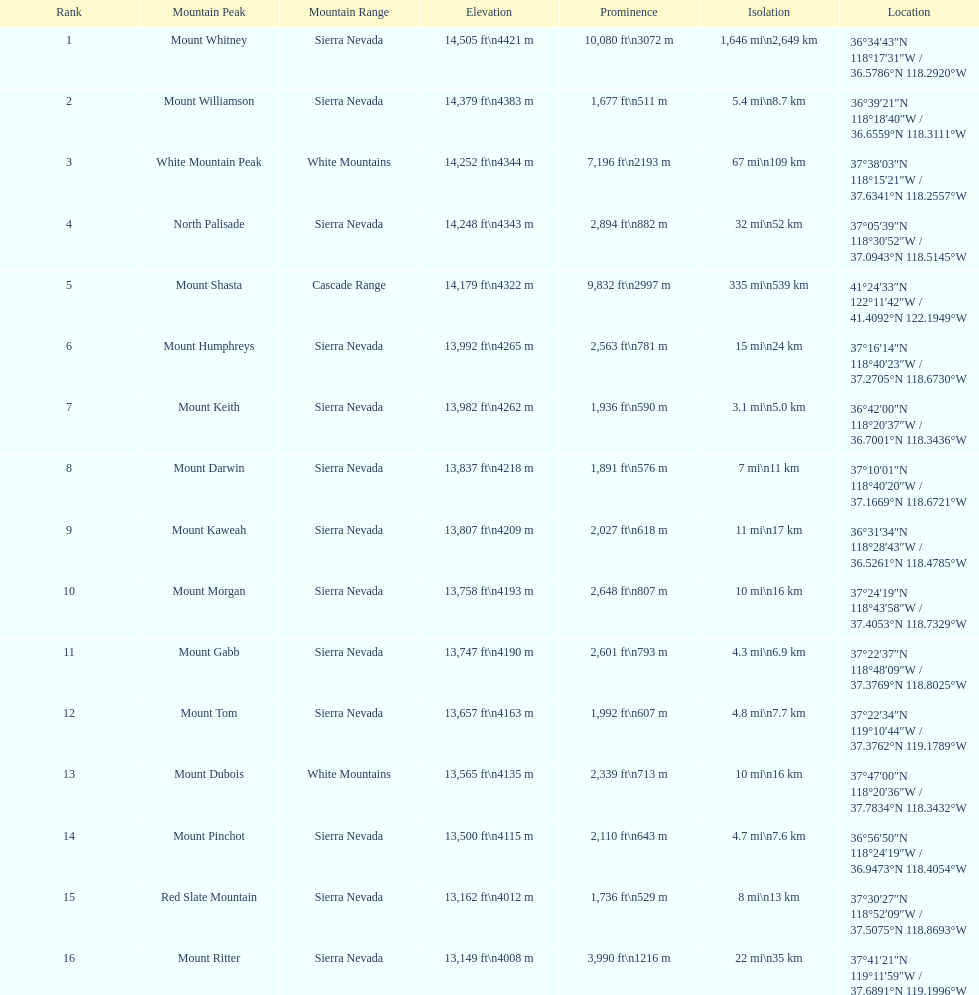What are the heights of the apexes? 14,505 ft\n4421 m, 14,379 ft\n4383 m, 14,252 ft\n4344 m, 14,248 ft\n4343 m, 14,179 ft\n4322 m, 13,992 ft\n4265 m, 13,982 ft\n4262 m, 13,837 ft\n4218 m, 13,807 ft\n4209 m, 13,758 ft\n4193 m, 13,747 ft\n4190 m, 13,657 ft\n4163 m, 13,565 ft\n4135 m, 13,500 ft\n4115 m, 13,162 ft\n4012 m, 13,149 ft\n4008 m. Which of these heights is the most elevated? 14,505 ft\n4421 m. What apex is 14,505 feet? Mount Whitney. 